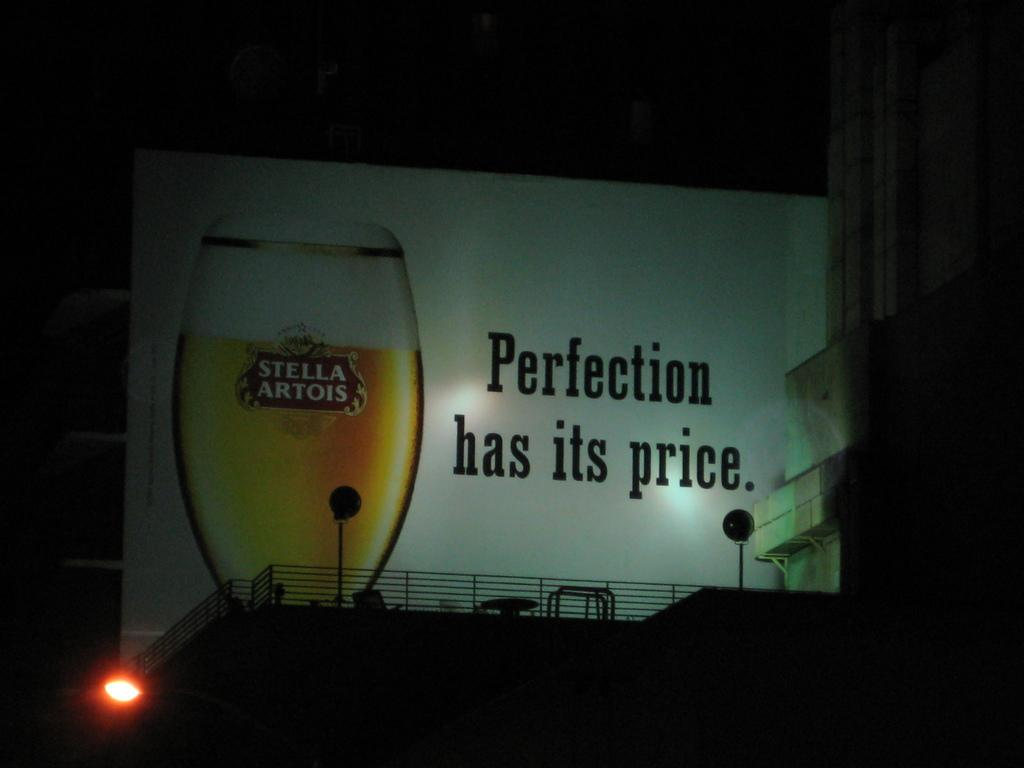Provide a one-sentence caption for the provided image. Billboard that says "Perfection has it's price" with a Stella Artois cup next toi t. 